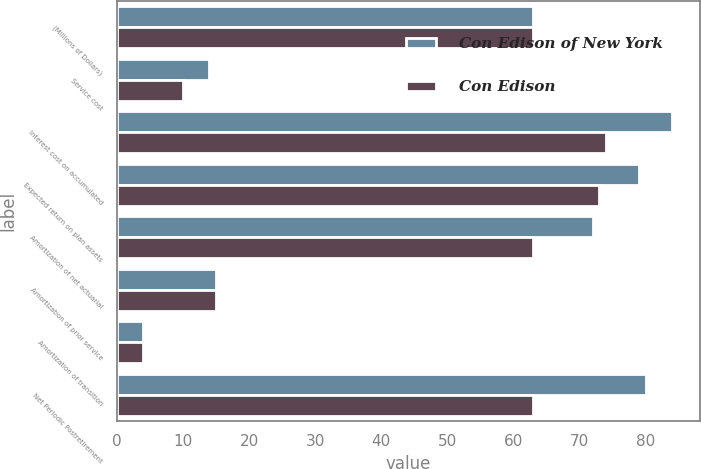<chart> <loc_0><loc_0><loc_500><loc_500><stacked_bar_chart><ecel><fcel>(Millions of Dollars)<fcel>Service cost<fcel>Interest cost on accumulated<fcel>Expected return on plan assets<fcel>Amortization of net actuarial<fcel>Amortization of prior service<fcel>Amortization of transition<fcel>Net Periodic Postretirement<nl><fcel>Con Edison of New York<fcel>63<fcel>14<fcel>84<fcel>79<fcel>72<fcel>15<fcel>4<fcel>80<nl><fcel>Con Edison<fcel>63<fcel>10<fcel>74<fcel>73<fcel>63<fcel>15<fcel>4<fcel>63<nl></chart> 